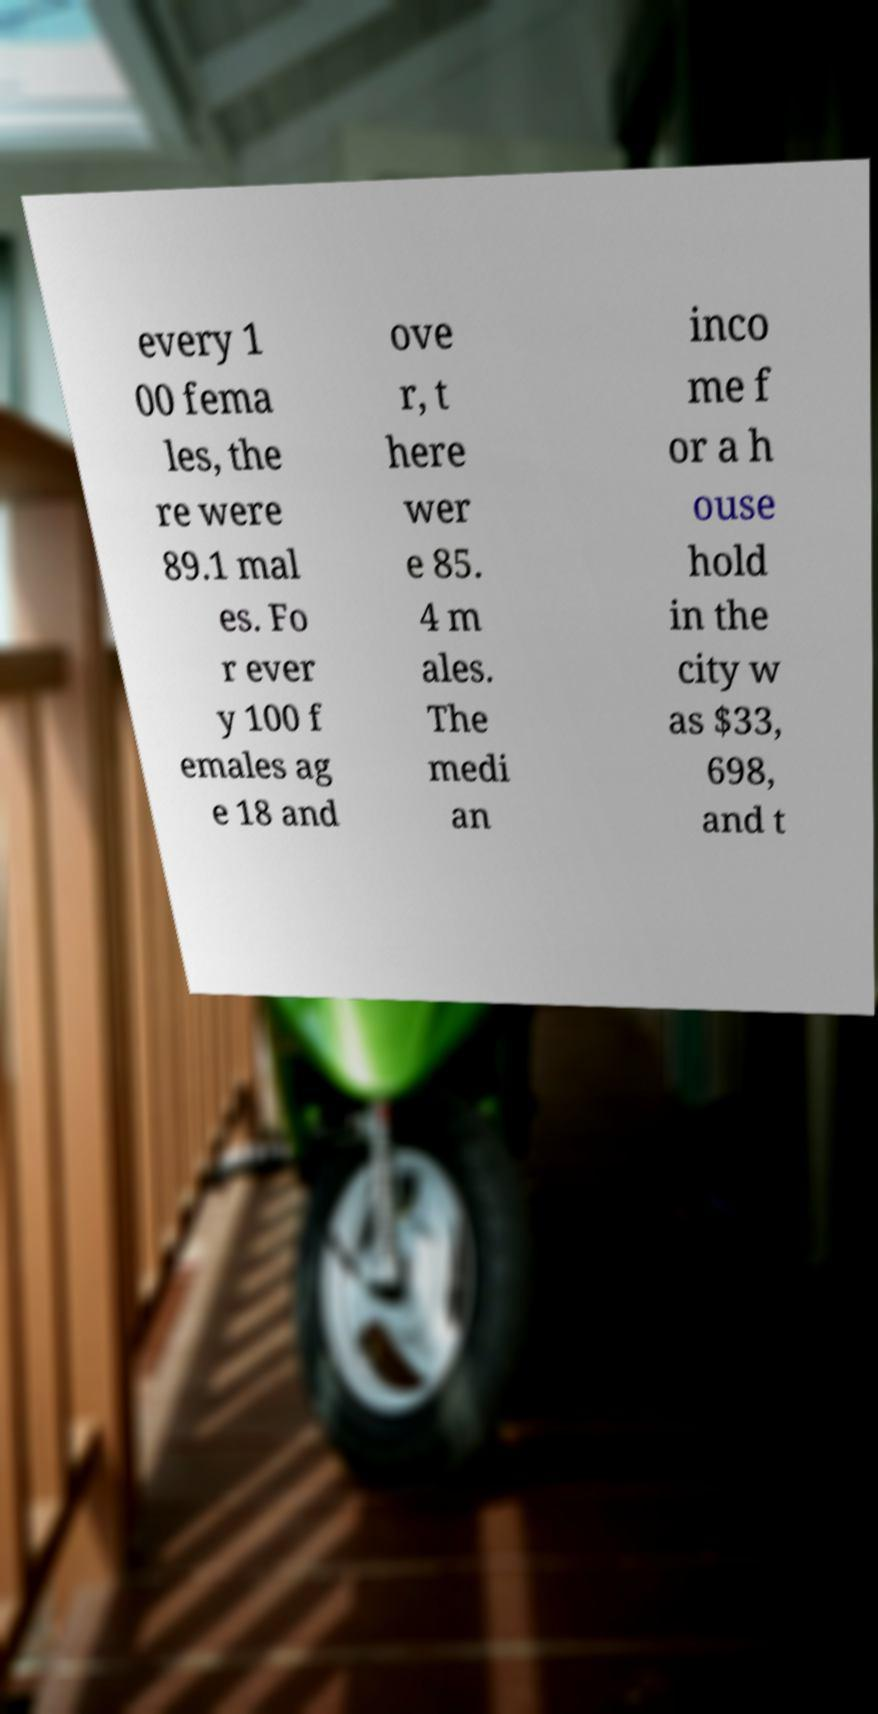Please identify and transcribe the text found in this image. every 1 00 fema les, the re were 89.1 mal es. Fo r ever y 100 f emales ag e 18 and ove r, t here wer e 85. 4 m ales. The medi an inco me f or a h ouse hold in the city w as $33, 698, and t 